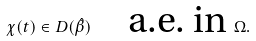Convert formula to latex. <formula><loc_0><loc_0><loc_500><loc_500>\chi ( t ) \in D ( \hat { \beta } ) \quad \text {a.e. in } \Omega .</formula> 